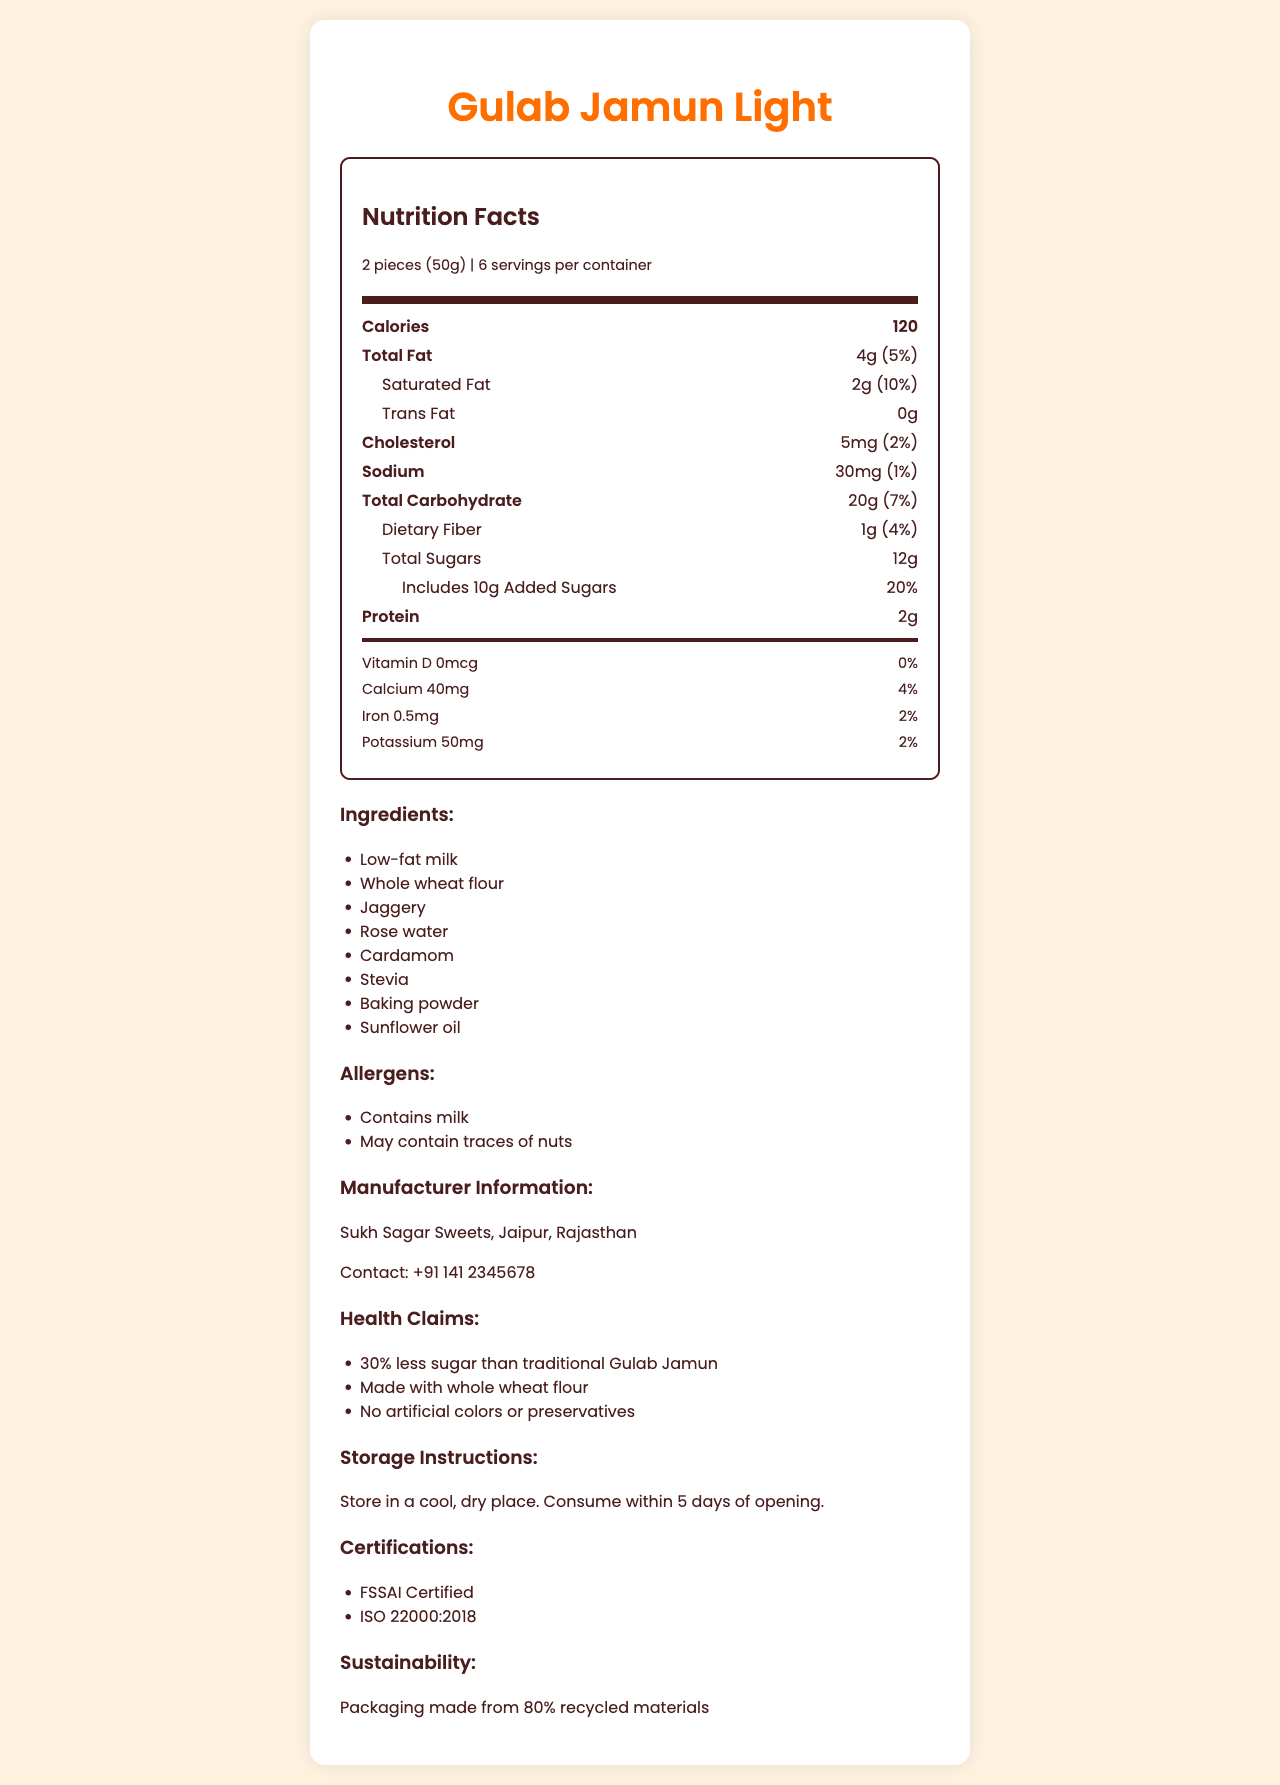what is the serving size for "Gulab Jamun Light"? The serving size is mentioned as "2 pieces (50g)" at the top of the Nutrition Facts.
Answer: 2 pieces (50g) how many calories are there per serving? The document indicates that there are 120 calories per serving.
Answer: 120 how much total fat is in one serving and what percentage of the daily value does it represent? The document states 4g of total fat per serving, which represents 5% of the daily value.
Answer: 4g, 5% What is the amount of dietary fiber per serving? The document mentions that there is 1g of dietary fiber per serving.
Answer: 1g what is the amount of calcium per serving and what percentage of the daily value does it represent? The document states that each serving contains 40mg of calcium, which is 4% of the daily value.
Answer: 40mg, 4% Which of the following is an ingredient in "Gulab Jamun Light"? A. High-fructose corn syrup B. Low-fat milk C. Palm oil The ingredient list includes "Low-fat milk," but not high-fructose corn syrup or palm oil.
Answer: B. Low-fat milk What is the amount of added sugars per serving and what percentage of the daily value does it represent? A. 12g, 20% B. 10g, 20% C. 10g, 10% The document states that there are 10g of added sugars, which constitute 20% of the daily value.
Answer: B. 10g, 20% Which certifications are awarded to "Gulab Jamun Light"? A. ISO 9001 B. FSSAI Certified C. ISO 22000:2018 D. Both B and C The "Certifications" section lists FSSAI Certified and ISO 22000:2018.
Answer: D. Both B and C Is "Gulab Jamun Light" sodium-free? The document indicates that there is 30mg of sodium per serving.
Answer: No Summarize the main idea of this document. The document describes the nutrition facts and health benefits of "Gulab Jamun Light," including its ingredients, nutritional content, and other relevant information like manufacturer details and certifications.
Answer: "Gulab Jamun Light" is a health-conscious version of Gulab Jamun, offering reduced sugar and made with healthier ingredients like low-fat milk and whole wheat flour. It provides detailed nutrition facts, ingredients, manufacturer information, health claims, storage instructions, certifications, and sustainability info. Who is the manufacturer of "Gulab Jamun Light"? The document lists "Sukh Sagar Sweets" as the manufacturer.
Answer: Sukh Sagar Sweets What is the amount of protein in one serving? The document states that there are 2g of protein per serving.
Answer: 2g How can "Gulab Jamun Light" be stored? The storage instructions are to store it in a cool, dry place and consume it within 5 days of opening.
Answer: Store in a cool, dry place. Consume within 5 days of opening. Does "Gulab Jamun Light" contain artificial colors or preservatives? The document states that it contains no artificial colors or preservatives.
Answer: No What is the address of the manufacturer? The document only provides the location "Jaipur, Rajasthan," but not a specific address.
Answer: Cannot be determined How does the calorie content of "Gulab Jamun Light" compare to traditional Gulab Jamun? The health claims mention that "Gulab Jamun Light" has 30% less sugar than traditional Gulab Jamun.
Answer: 30% less sugar than traditional Gulab Jamun 